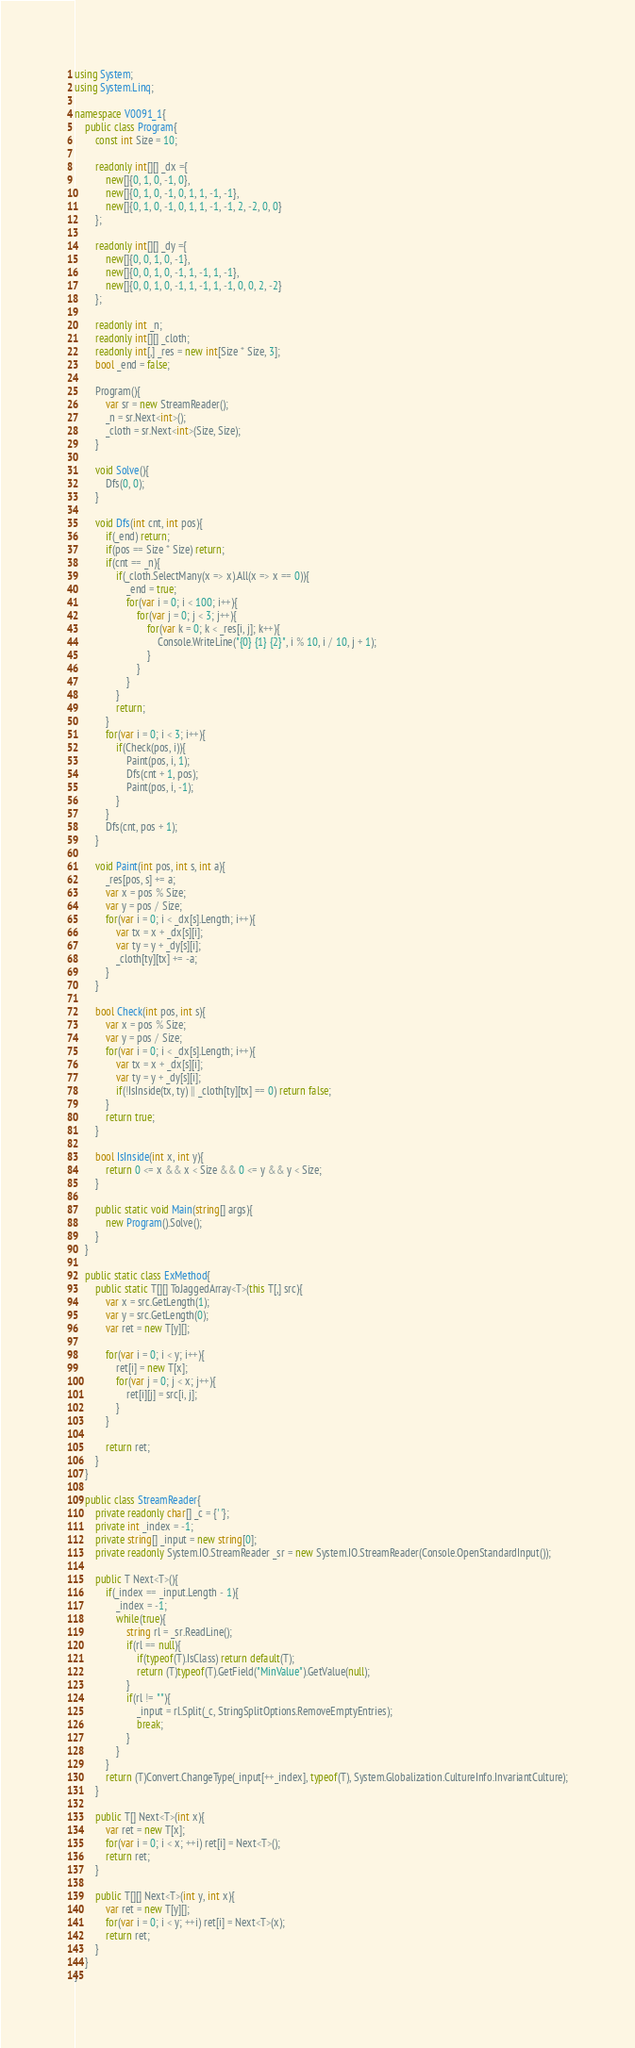Convert code to text. <code><loc_0><loc_0><loc_500><loc_500><_C#_>using System;
using System.Linq;

namespace V0091_1{
    public class Program{
        const int Size = 10;

        readonly int[][] _dx ={
            new[]{0, 1, 0, -1, 0},
            new[]{0, 1, 0, -1, 0, 1, 1, -1, -1},
            new[]{0, 1, 0, -1, 0, 1, 1, -1, -1, 2, -2, 0, 0}
        };

        readonly int[][] _dy ={
            new[]{0, 0, 1, 0, -1},
            new[]{0, 0, 1, 0, -1, 1, -1, 1, -1},
            new[]{0, 0, 1, 0, -1, 1, -1, 1, -1, 0, 0, 2, -2}
        };

        readonly int _n;
        readonly int[][] _cloth;
        readonly int[,] _res = new int[Size * Size, 3];
        bool _end = false;

        Program(){
            var sr = new StreamReader();
            _n = sr.Next<int>();
            _cloth = sr.Next<int>(Size, Size);
        }

        void Solve(){
            Dfs(0, 0);
        }

        void Dfs(int cnt, int pos){
            if(_end) return;
            if(pos == Size * Size) return;
            if(cnt == _n){
                if(_cloth.SelectMany(x => x).All(x => x == 0)){
                    _end = true;
                    for(var i = 0; i < 100; i++){
                        for(var j = 0; j < 3; j++){
                            for(var k = 0; k < _res[i, j]; k++){
                                Console.WriteLine("{0} {1} {2}", i % 10, i / 10, j + 1);
                            }
                        }
                    }
                }
                return;
            }
            for(var i = 0; i < 3; i++){
                if(Check(pos, i)){
                    Paint(pos, i, 1);
                    Dfs(cnt + 1, pos);
                    Paint(pos, i, -1);
                }
            }
            Dfs(cnt, pos + 1);
        }

        void Paint(int pos, int s, int a){
            _res[pos, s] += a;
            var x = pos % Size;
            var y = pos / Size;
            for(var i = 0; i < _dx[s].Length; i++){
                var tx = x + _dx[s][i];
                var ty = y + _dy[s][i];
                _cloth[ty][tx] += -a;
            }
        }

        bool Check(int pos, int s){
            var x = pos % Size;
            var y = pos / Size;
            for(var i = 0; i < _dx[s].Length; i++){
                var tx = x + _dx[s][i];
                var ty = y + _dy[s][i];
                if(!IsInside(tx, ty) || _cloth[ty][tx] == 0) return false;
            }
            return true;
        }

        bool IsInside(int x, int y){
            return 0 <= x && x < Size && 0 <= y && y < Size;
        }

        public static void Main(string[] args){
            new Program().Solve();
        }
    }

    public static class ExMethod{
        public static T[][] ToJaggedArray<T>(this T[,] src){
            var x = src.GetLength(1);
            var y = src.GetLength(0);
            var ret = new T[y][];

            for(var i = 0; i < y; i++){
                ret[i] = new T[x];
                for(var j = 0; j < x; j++){
                    ret[i][j] = src[i, j];
                }
            }

            return ret;
        }
    }

    public class StreamReader{
        private readonly char[] _c = {' '};
        private int _index = -1;
        private string[] _input = new string[0];
        private readonly System.IO.StreamReader _sr = new System.IO.StreamReader(Console.OpenStandardInput());

        public T Next<T>(){
            if(_index == _input.Length - 1){
                _index = -1;
                while(true){
                    string rl = _sr.ReadLine();
                    if(rl == null){
                        if(typeof(T).IsClass) return default(T);
                        return (T)typeof(T).GetField("MinValue").GetValue(null);
                    }
                    if(rl != ""){
                        _input = rl.Split(_c, StringSplitOptions.RemoveEmptyEntries);
                        break;
                    }
                }
            }
            return (T)Convert.ChangeType(_input[++_index], typeof(T), System.Globalization.CultureInfo.InvariantCulture);
        }

        public T[] Next<T>(int x){
            var ret = new T[x];
            for(var i = 0; i < x; ++i) ret[i] = Next<T>();
            return ret;
        }

        public T[][] Next<T>(int y, int x){
            var ret = new T[y][];
            for(var i = 0; i < y; ++i) ret[i] = Next<T>(x);
            return ret;
        }
    }
}</code> 